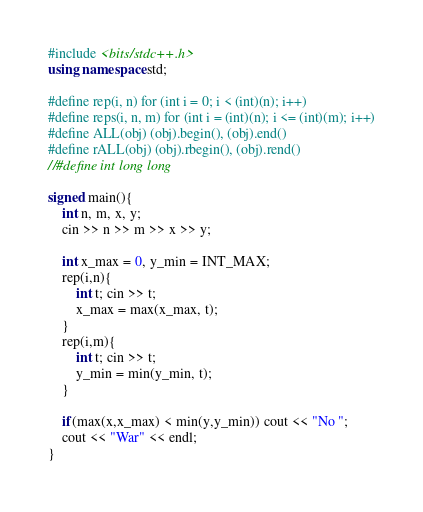<code> <loc_0><loc_0><loc_500><loc_500><_C++_>#include <bits/stdc++.h>
using namespace std;

#define rep(i, n) for (int i = 0; i < (int)(n); i++)
#define reps(i, n, m) for (int i = (int)(n); i <= (int)(m); i++)
#define ALL(obj) (obj).begin(), (obj).end()
#define rALL(obj) (obj).rbegin(), (obj).rend()
//#define int long long

signed main(){
    int n, m, x, y;
    cin >> n >> m >> x >> y;
    
    int x_max = 0, y_min = INT_MAX;
    rep(i,n){
        int t; cin >> t;
        x_max = max(x_max, t);
    }
    rep(i,m){
        int t; cin >> t;
        y_min = min(y_min, t);
    }
    
    if(max(x,x_max) < min(y,y_min)) cout << "No ";
    cout << "War" << endl;
}</code> 